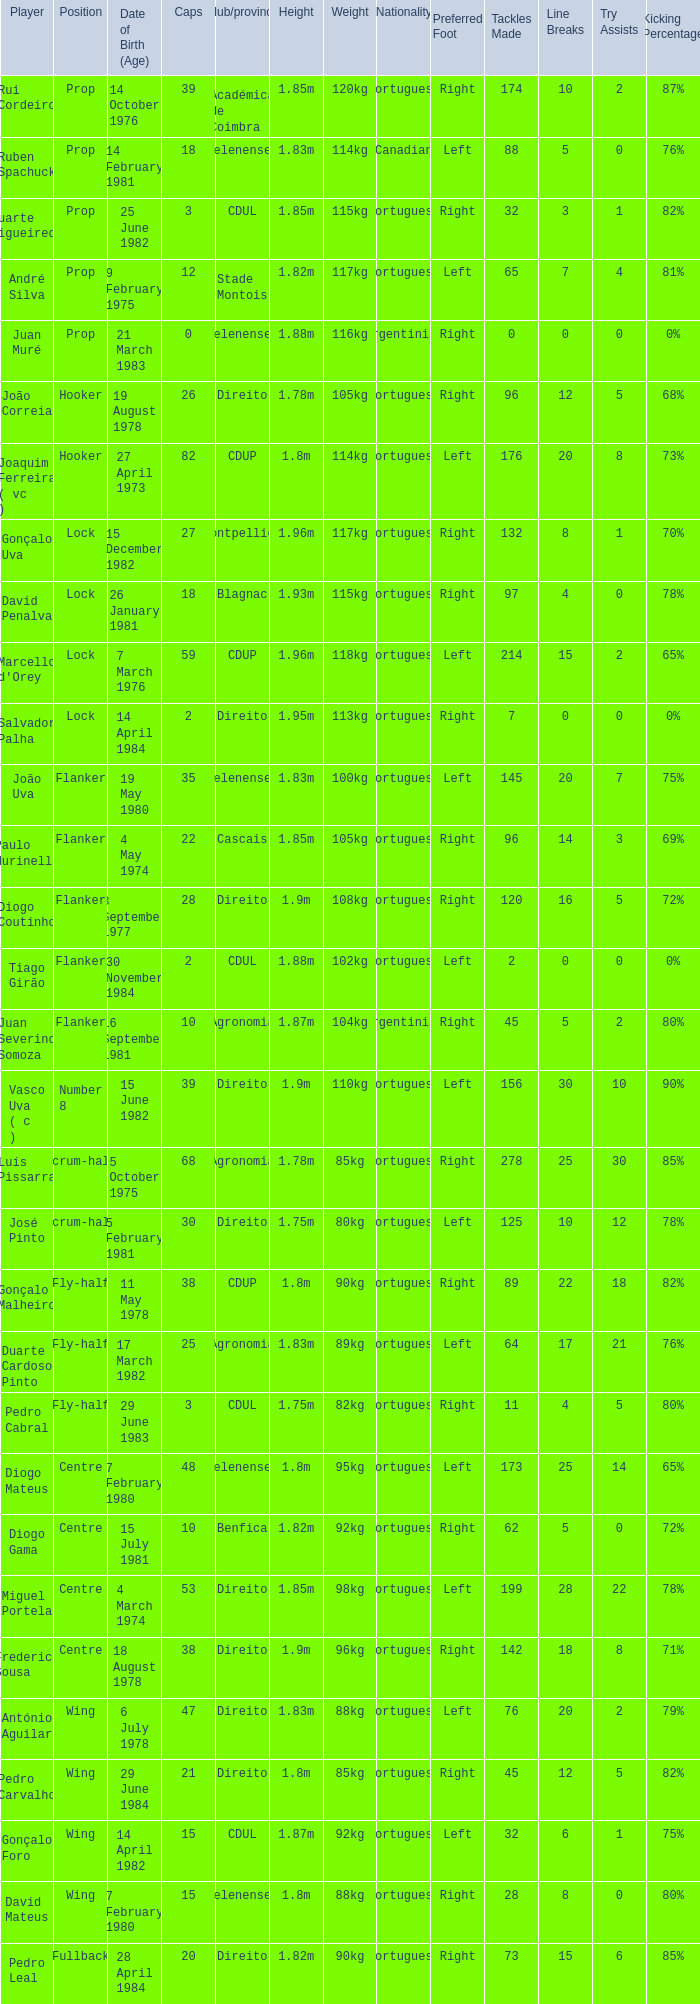Which player has a Position of fly-half, and a Caps of 3? Pedro Cabral. 